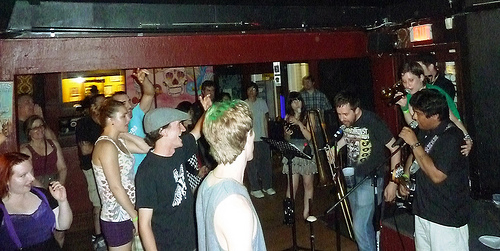<image>
Is the man to the left of the woman? No. The man is not to the left of the woman. From this viewpoint, they have a different horizontal relationship. 